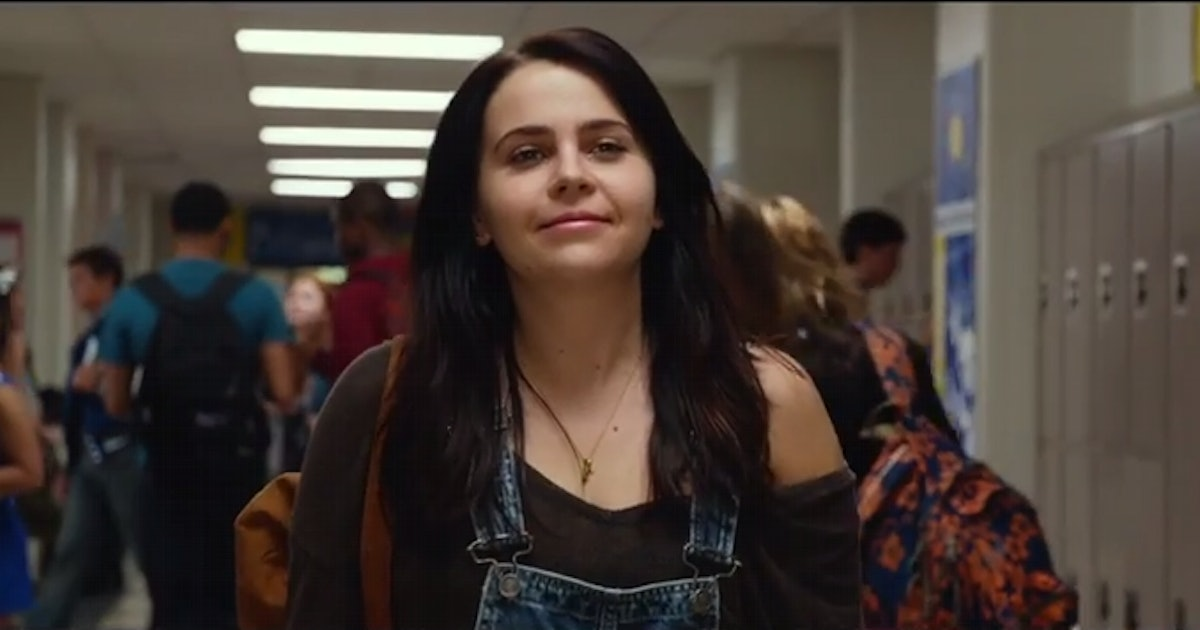How does the background activity contribute to the overall atmosphere of this scene? The bustling atmosphere of the hallway filled with students walking in various directions adds a dynamic and lively backdrop to the scene. It enhances the feeling of a busy school environment, emphasizing the social aspect of school life. This movement contrasts nicely with the character's calm demeanor, highlighting her as the focal point in this active setting. 